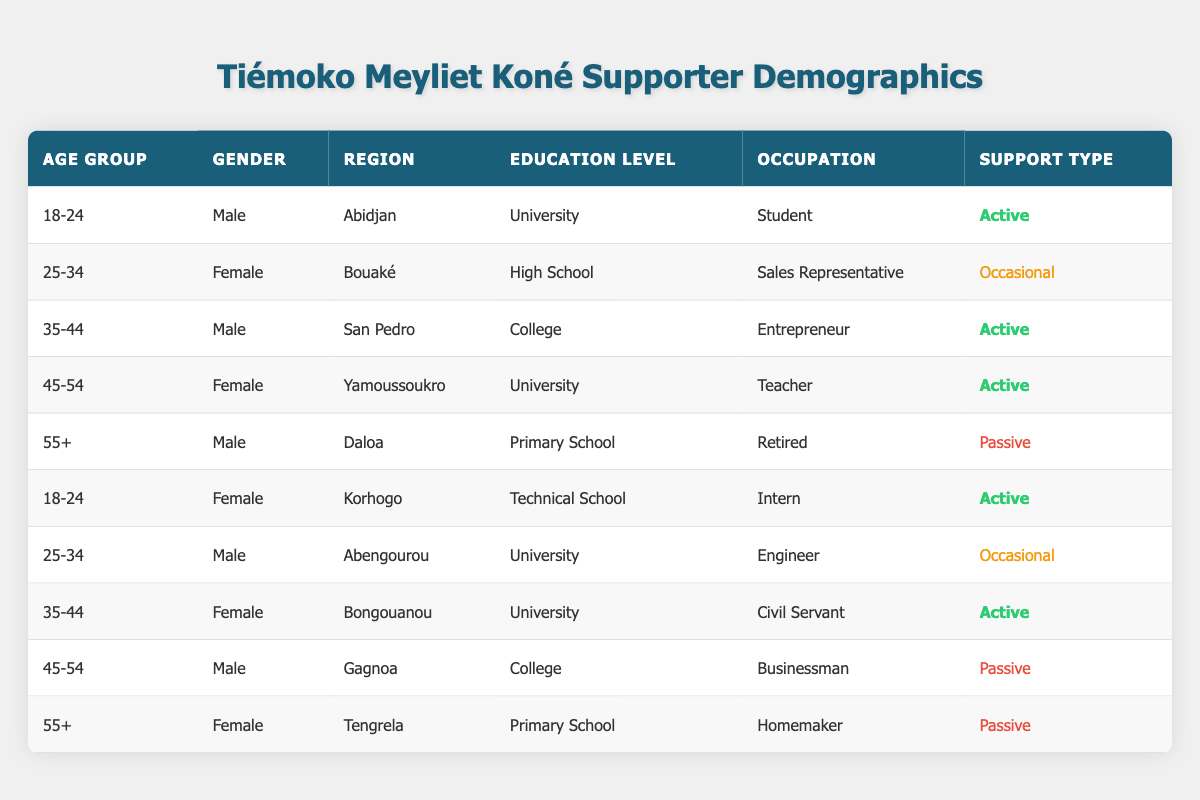What is the occupation of the supporter from Bouaké? Referring to the table, the row that contains the region Bouaké shows the occupation as Sales Representative.
Answer: Sales Representative How many supporters are in the age group 35-44? Looking at the table, there are two entries for the age group 35-44: one for a Male in San Pedro and one for a Female in Bongouanou. Thus, the count is 2.
Answer: 2 Is there any supporter aged 55 or older who is active? Examining the two rows with supporters aged 55+, both are characterized as Passive (one Male in Daloa and one Female in Tengrela), indicating that there are no active supporters in this age group.
Answer: No What is the total number of Male supporters who are classified as Active? From the table, the Male supporters who are classified as Active are those aged 18-24 in Abidjan, 35-44 in San Pedro, and 35-44 in Bongouanou. There are three Active Male supporters in total.
Answer: 3 What percentage of supporters are from Abidjan? There is one supporter from Abidjan out of a total of 10 supporters. To find the percentage, we calculate (1/10) * 100, yielding 10%.
Answer: 10% Which region has the Female supporter with the highest education level? The Female supporter with the highest education level (University) is the one from Yamoussoukro who is aged 45-54.
Answer: Yamoussoukro How many supporters between 25-34 years of age are considered Passive? There are no supporters in the age group 25-34 classified as Passive according to the table, as both entries for that age group (one Female in Bouaké and one Male in Abengourou) are categorized as either Occasional or Active.
Answer: 0 Which gender has a higher representation in the age group 18-24? There are two supporters aged 18-24: one Male from Abidjan and one Female from Korhogo. Both genders are equally represented in this age group.
Answer: Equal representation How many total passive supporters are there? The Passive supporters are those aged 55+ (one Male in Daloa and one Female in Tengrela) and one Male aged 45-54 in Gagnoa. Thus, there are three Passive supporters in total.
Answer: 3 